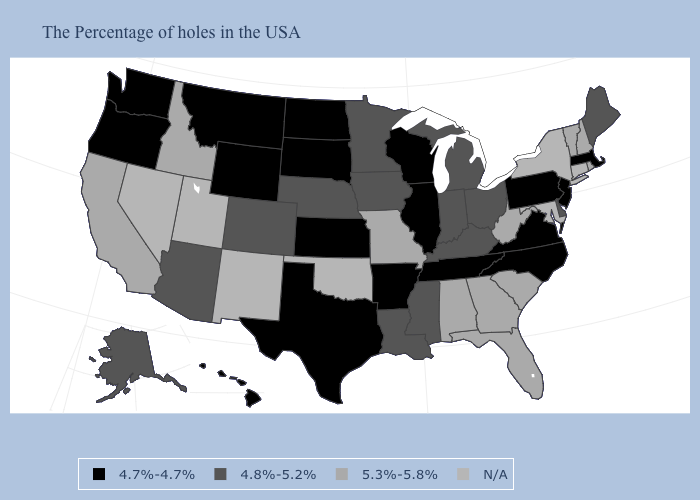Which states hav the highest value in the MidWest?
Concise answer only. Missouri. Name the states that have a value in the range 4.8%-5.2%?
Short answer required. Maine, Delaware, Ohio, Michigan, Kentucky, Indiana, Mississippi, Louisiana, Minnesota, Iowa, Nebraska, Colorado, Arizona, Alaska. Name the states that have a value in the range 4.8%-5.2%?
Answer briefly. Maine, Delaware, Ohio, Michigan, Kentucky, Indiana, Mississippi, Louisiana, Minnesota, Iowa, Nebraska, Colorado, Arizona, Alaska. What is the value of Arkansas?
Short answer required. 4.7%-4.7%. Name the states that have a value in the range N/A?
Quick response, please. Connecticut, New York, Maryland, Oklahoma, New Mexico, Utah, Nevada. Does Massachusetts have the lowest value in the Northeast?
Be succinct. Yes. Name the states that have a value in the range 5.3%-5.8%?
Answer briefly. Rhode Island, New Hampshire, Vermont, South Carolina, West Virginia, Florida, Georgia, Alabama, Missouri, Idaho, California. Name the states that have a value in the range 5.3%-5.8%?
Answer briefly. Rhode Island, New Hampshire, Vermont, South Carolina, West Virginia, Florida, Georgia, Alabama, Missouri, Idaho, California. Name the states that have a value in the range 5.3%-5.8%?
Be succinct. Rhode Island, New Hampshire, Vermont, South Carolina, West Virginia, Florida, Georgia, Alabama, Missouri, Idaho, California. Among the states that border Utah , which have the lowest value?
Keep it brief. Wyoming. Which states have the lowest value in the South?
Keep it brief. Virginia, North Carolina, Tennessee, Arkansas, Texas. Does the first symbol in the legend represent the smallest category?
Give a very brief answer. Yes. What is the value of New Mexico?
Answer briefly. N/A. What is the highest value in the USA?
Short answer required. 5.3%-5.8%. Name the states that have a value in the range N/A?
Be succinct. Connecticut, New York, Maryland, Oklahoma, New Mexico, Utah, Nevada. 